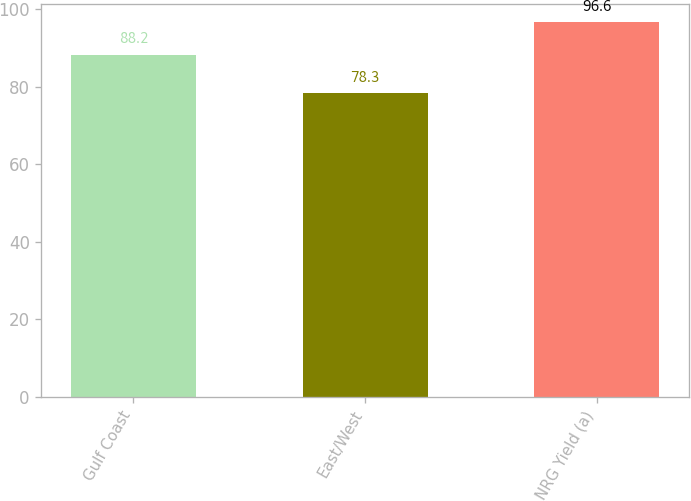Convert chart. <chart><loc_0><loc_0><loc_500><loc_500><bar_chart><fcel>Gulf Coast<fcel>East/West<fcel>NRG Yield (a)<nl><fcel>88.2<fcel>78.3<fcel>96.6<nl></chart> 